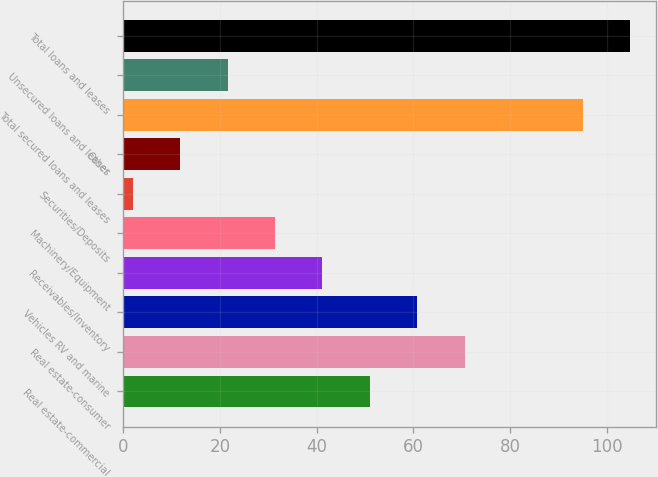<chart> <loc_0><loc_0><loc_500><loc_500><bar_chart><fcel>Real estate-commercial<fcel>Real estate-consumer<fcel>Vehicles RV and marine<fcel>Receivables/Inventory<fcel>Machinery/Equipment<fcel>Securities/Deposits<fcel>Other<fcel>Total secured loans and leases<fcel>Unsecured loans and leases<fcel>Total loans and leases<nl><fcel>51<fcel>70.6<fcel>60.8<fcel>41.2<fcel>31.4<fcel>2<fcel>11.8<fcel>95<fcel>21.6<fcel>104.8<nl></chart> 